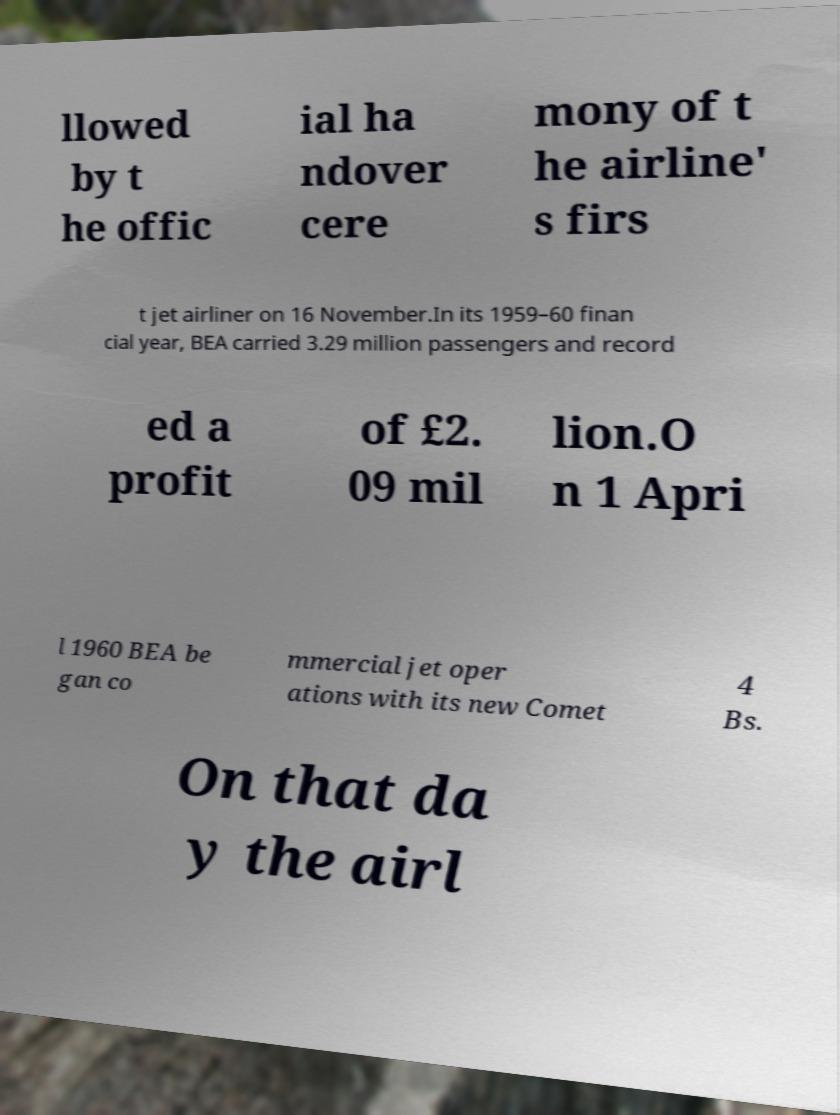Can you read and provide the text displayed in the image?This photo seems to have some interesting text. Can you extract and type it out for me? llowed by t he offic ial ha ndover cere mony of t he airline' s firs t jet airliner on 16 November.In its 1959–60 finan cial year, BEA carried 3.29 million passengers and record ed a profit of £2. 09 mil lion.O n 1 Apri l 1960 BEA be gan co mmercial jet oper ations with its new Comet 4 Bs. On that da y the airl 